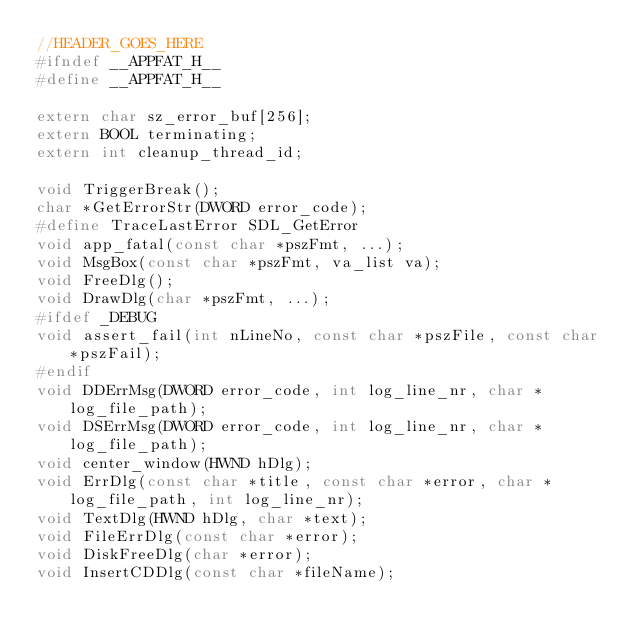<code> <loc_0><loc_0><loc_500><loc_500><_C_>//HEADER_GOES_HERE
#ifndef __APPFAT_H__
#define __APPFAT_H__

extern char sz_error_buf[256];
extern BOOL terminating;
extern int cleanup_thread_id;

void TriggerBreak();
char *GetErrorStr(DWORD error_code);
#define TraceLastError SDL_GetError
void app_fatal(const char *pszFmt, ...);
void MsgBox(const char *pszFmt, va_list va);
void FreeDlg();
void DrawDlg(char *pszFmt, ...);
#ifdef _DEBUG
void assert_fail(int nLineNo, const char *pszFile, const char *pszFail);
#endif
void DDErrMsg(DWORD error_code, int log_line_nr, char *log_file_path);
void DSErrMsg(DWORD error_code, int log_line_nr, char *log_file_path);
void center_window(HWND hDlg);
void ErrDlg(const char *title, const char *error, char *log_file_path, int log_line_nr);
void TextDlg(HWND hDlg, char *text);
void FileErrDlg(const char *error);
void DiskFreeDlg(char *error);
void InsertCDDlg(const char *fileName);</code> 